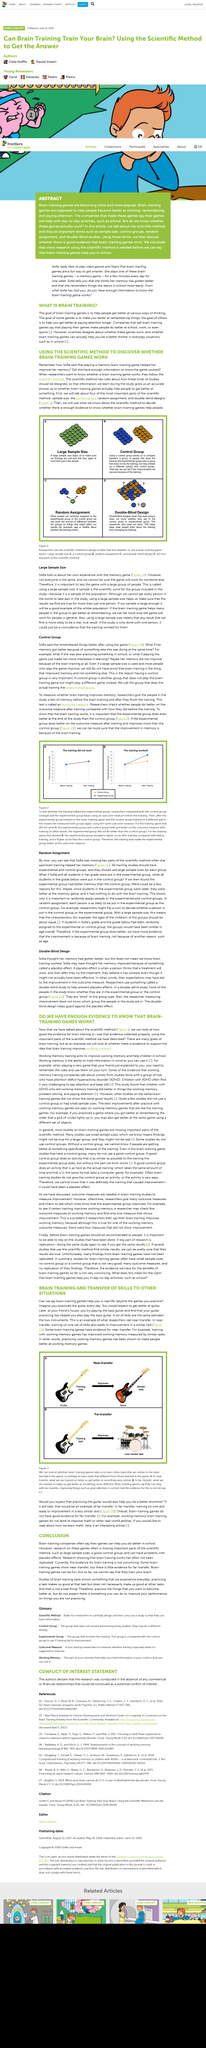Highlight a few significant elements in this photo. Companies that sell brain-training games claim that playing their games leads to improved performance in school, work, and even sports. The article examines the evidence for improving 'working memory'. Brain-training companies frequently claim that their games can improve academic performance in students. The goal of brain training games is to improve various cognitive abilities in individuals to enhance their overall thinking skills. Yes, some brain training games have evidence of near-transfer. 